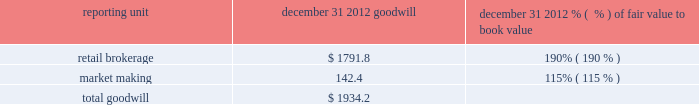There is no goodwill assigned to reporting units within the balance sheet management segment .
The table shows the amount of goodwill allocated to each of the reporting units and the fair value as a percentage of book value for the reporting units in the trading and investing segment ( dollars in millions ) : .
We also evaluate the remaining useful lives on intangible assets each reporting period to determine whether events and circumstances warrant a revision to the remaining period of amortization .
Other intangible assets have a weighted average remaining useful life of 13 years .
We did not recognize impairment on our other intangible assets in the periods presented .
Effects if actual results differ if our estimates of fair value for the reporting units change due to changes in our business or other factors , we may determine that an impairment charge is necessary .
Estimates of fair value are determined based on a complex model using estimated future cash flows and company comparisons .
If actual cash flows are less than estimated future cash flows used in the annual assessment , then goodwill would have to be tested for impairment .
The estimated fair value of the market making reporting unit as a percentage of book value was approximately 115% ( 115 % ) ; therefore , if actual cash flows are less than our estimated cash flows , goodwill impairment could occur in the market making reporting unit in the future .
These cash flows will be monitored closely to determine if a further evaluation of potential impairment is necessary so that impairment could be recognized in a timely manner .
In addition , following the review of order handling practices and pricing for order flow between e*trade securities llc and gi execution services , llc , our regulators may initiate investigations into our historical practices which could subject us to monetary penalties and cease-and-desist orders , which could also prompt claims by customers of e*trade securities llc .
Any of these actions could materially and adversely affect our market making and trade execution businesses , which could impact future cash flows and could result in goodwill impairment .
Intangible assets are amortized over their estimated useful lives .
If changes in the estimated underlying revenue occur , impairment or a change in the remaining life may need to be recognized .
Estimates of effective tax rates , deferred taxes and valuation allowance description in preparing the consolidated financial statements , we calculate income tax expense ( benefit ) based on our interpretation of the tax laws in the various jurisdictions where we conduct business .
This requires us to estimate current tax obligations and the realizability of uncertain tax positions and to assess temporary differences between the financial statement carrying amounts and the tax basis of assets and liabilities .
These differences result in deferred tax assets and liabilities , the net amount of which we show as other assets or other liabilities on the consolidated balance sheet .
We must also assess the likelihood that each of the deferred tax assets will be realized .
To the extent we believe that realization is not more likely than not , we establish a valuation allowance .
When we establish a valuation allowance or increase this allowance in a reporting period , we generally record a corresponding tax expense in the consolidated statement of income ( loss ) .
Conversely , to the extent circumstances indicate that a valuation allowance is no longer necessary , that portion of the valuation allowance is reversed , which generally reduces overall income tax expense .
At december 31 , 2012 we had net deferred tax assets of $ 1416.2 million , net of a valuation allowance ( on state , foreign country and charitable contribution deferred tax assets ) of $ 97.8 million. .
As of december 2012 what was the ratio of the retail brokerage to market making goodwill? 
Rationale: as of december 2012 there was $ 12.6 for retail brokerage per $ 1 market making goodwill
Computations: (1791.8 / 142.4)
Answer: 12.58287. 